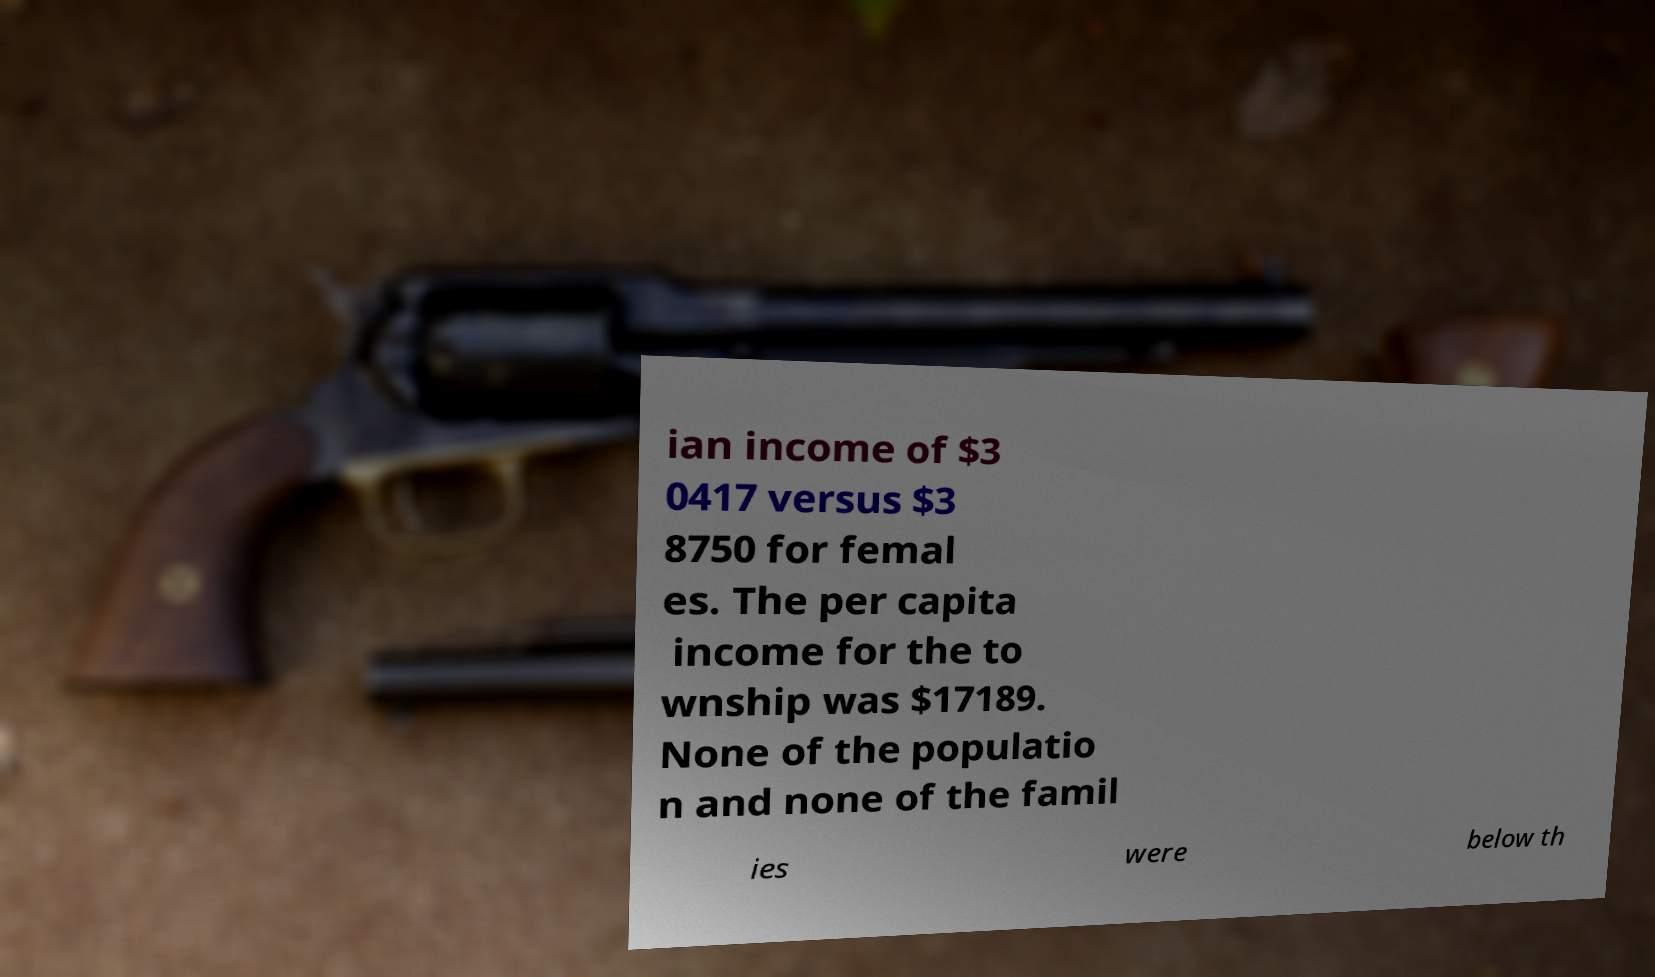I need the written content from this picture converted into text. Can you do that? ian income of $3 0417 versus $3 8750 for femal es. The per capita income for the to wnship was $17189. None of the populatio n and none of the famil ies were below th 